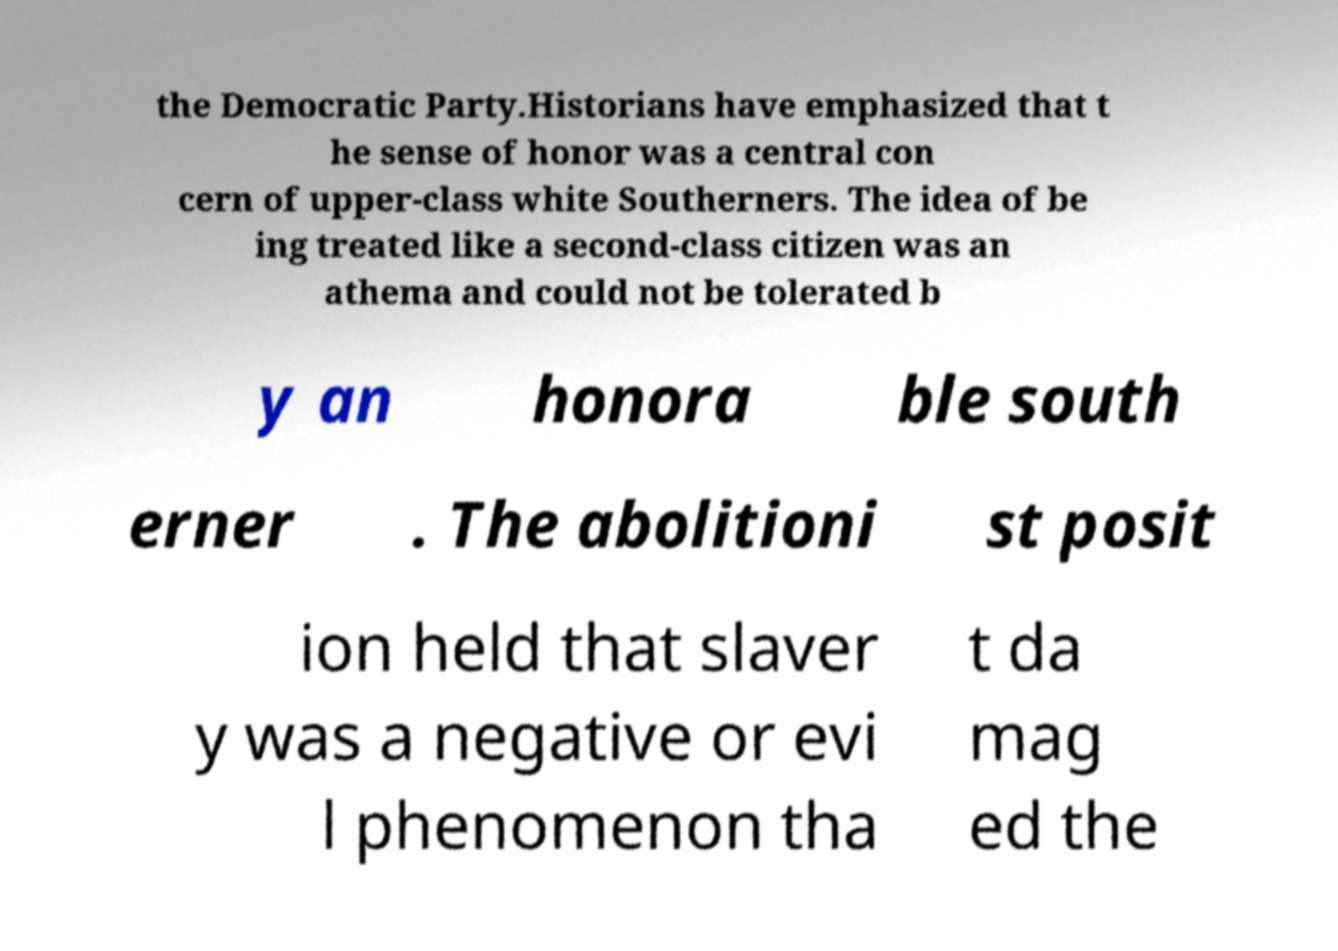Can you read and provide the text displayed in the image?This photo seems to have some interesting text. Can you extract and type it out for me? the Democratic Party.Historians have emphasized that t he sense of honor was a central con cern of upper-class white Southerners. The idea of be ing treated like a second-class citizen was an athema and could not be tolerated b y an honora ble south erner . The abolitioni st posit ion held that slaver y was a negative or evi l phenomenon tha t da mag ed the 